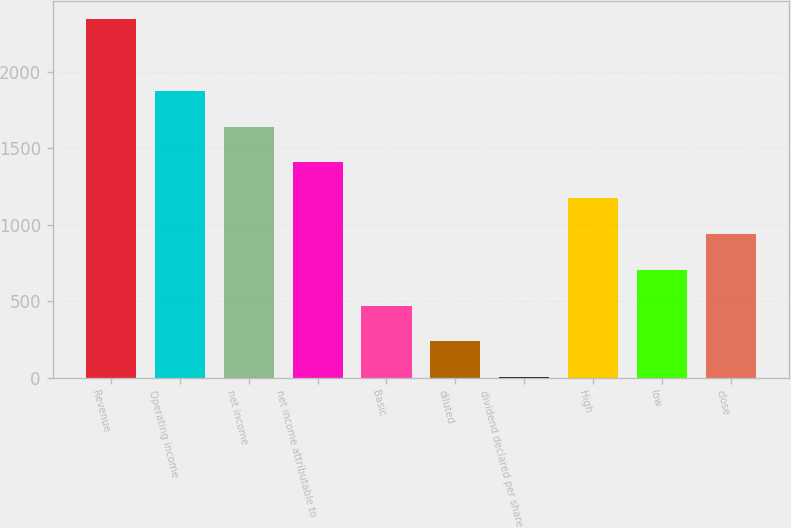<chart> <loc_0><loc_0><loc_500><loc_500><bar_chart><fcel>Revenue<fcel>Operating income<fcel>net income<fcel>net income attributable to<fcel>Basic<fcel>diluted<fcel>dividend declared per share<fcel>High<fcel>low<fcel>close<nl><fcel>2347<fcel>1877.86<fcel>1643.3<fcel>1408.74<fcel>470.5<fcel>235.94<fcel>1.38<fcel>1174.18<fcel>705.06<fcel>939.62<nl></chart> 